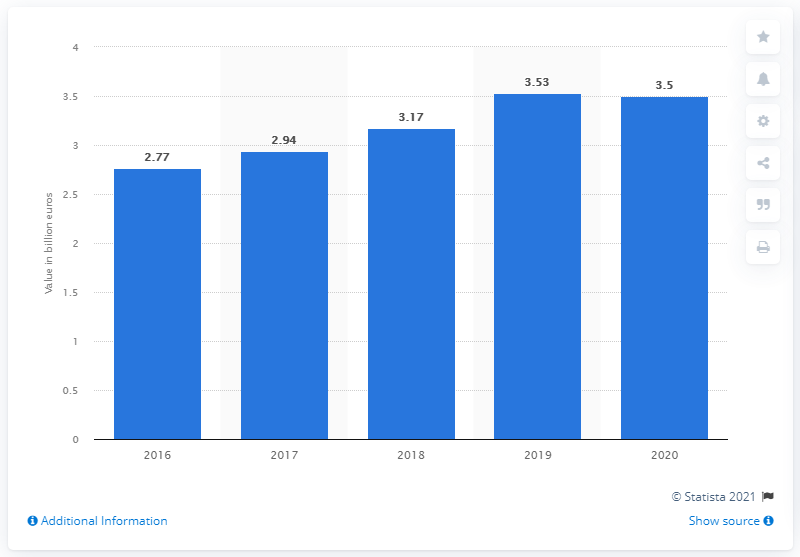Specify some key components in this picture. In 2020, the export value of textiles and textile articles from Vietnam to the European Union reached 3.5 billion euros. The export value of textiles from Vietnam to the European Union in 2020 was 3.5 billion USD. 